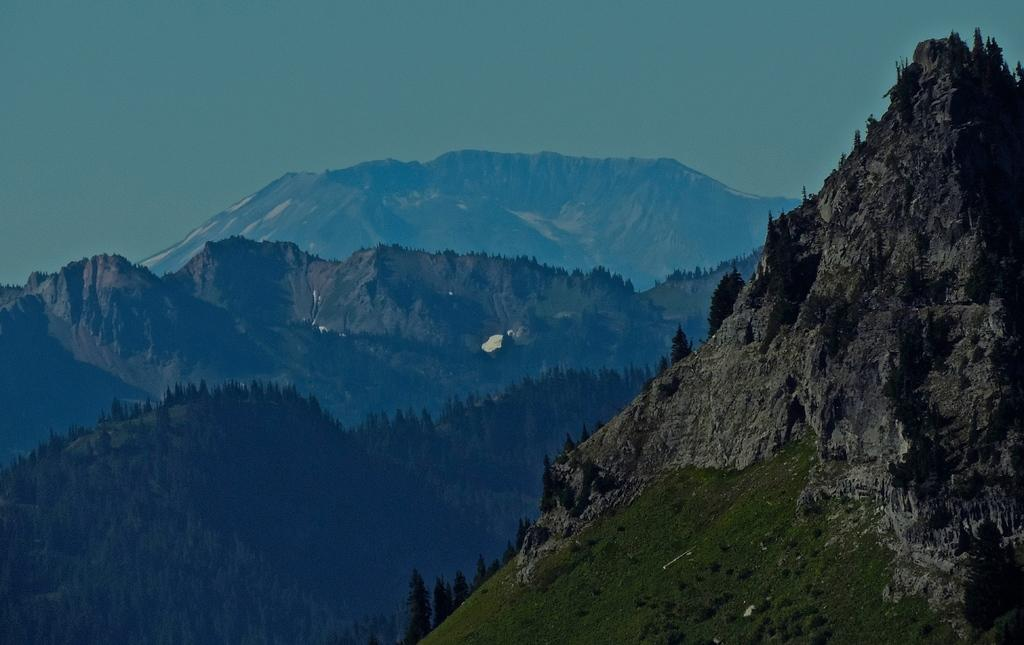What type of natural landscape is depicted in the image? The image features mountains. What other natural elements can be seen in the image? There are trees in the image. Can you see a cat climbing one of the mountains in the image? There is no cat present in the image. Is there any mention of credit or financial transactions in the image? There is no reference to credit or financial transactions in the image. 